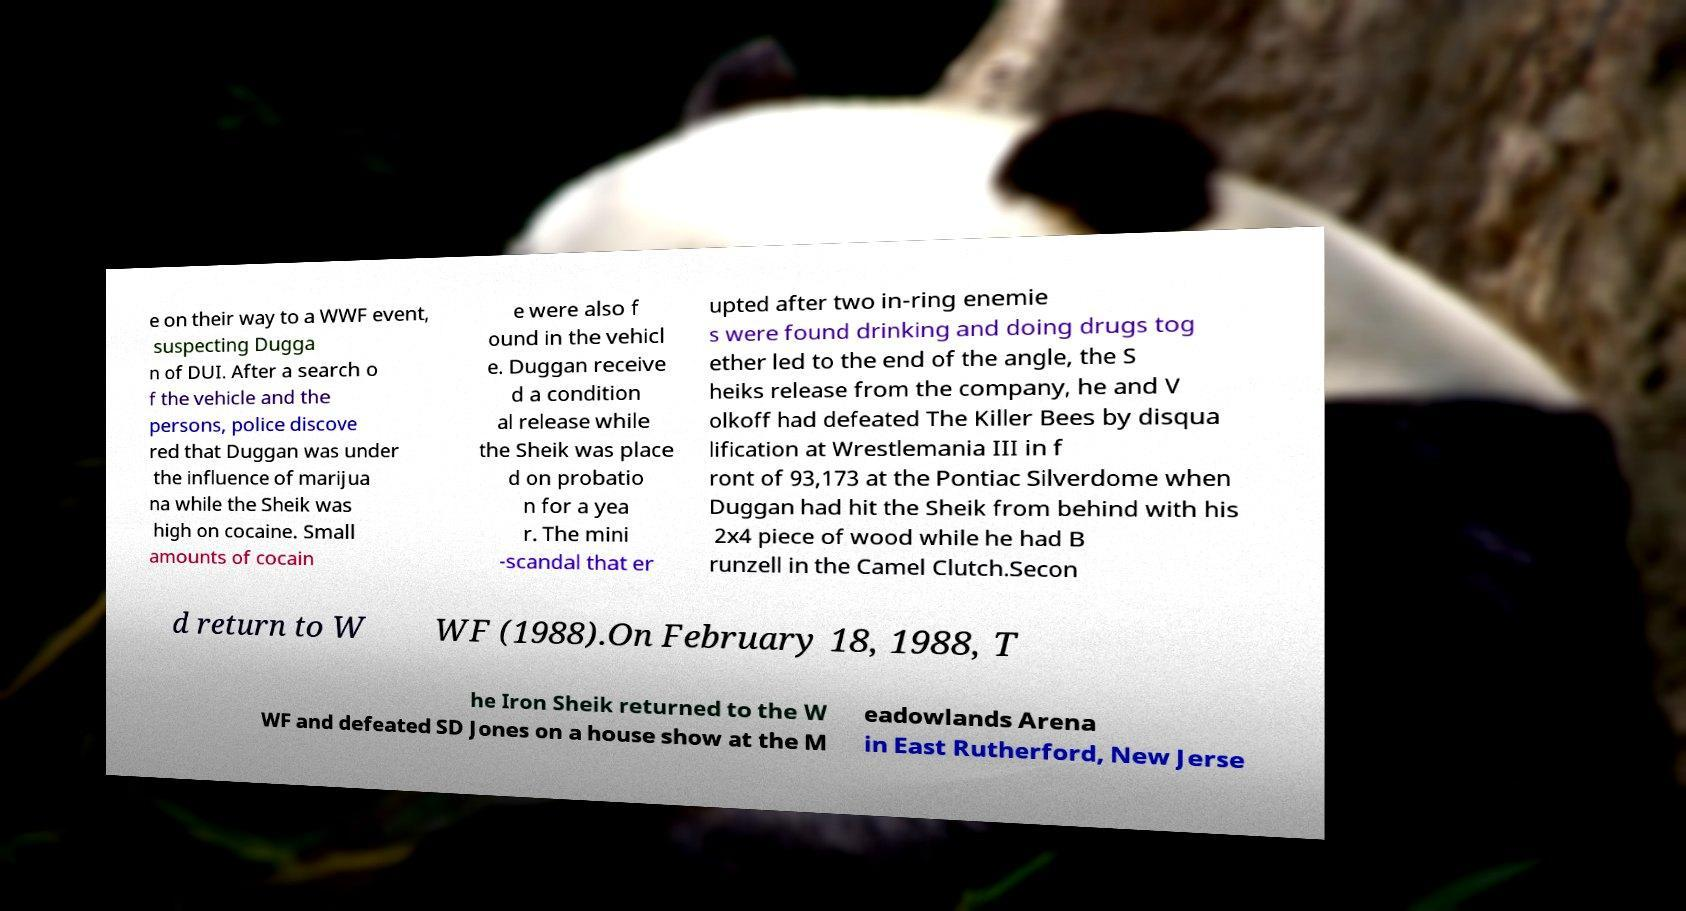Could you extract and type out the text from this image? e on their way to a WWF event, suspecting Dugga n of DUI. After a search o f the vehicle and the persons, police discove red that Duggan was under the influence of marijua na while the Sheik was high on cocaine. Small amounts of cocain e were also f ound in the vehicl e. Duggan receive d a condition al release while the Sheik was place d on probatio n for a yea r. The mini -scandal that er upted after two in-ring enemie s were found drinking and doing drugs tog ether led to the end of the angle, the S heiks release from the company, he and V olkoff had defeated The Killer Bees by disqua lification at Wrestlemania III in f ront of 93,173 at the Pontiac Silverdome when Duggan had hit the Sheik from behind with his 2x4 piece of wood while he had B runzell in the Camel Clutch.Secon d return to W WF (1988).On February 18, 1988, T he Iron Sheik returned to the W WF and defeated SD Jones on a house show at the M eadowlands Arena in East Rutherford, New Jerse 